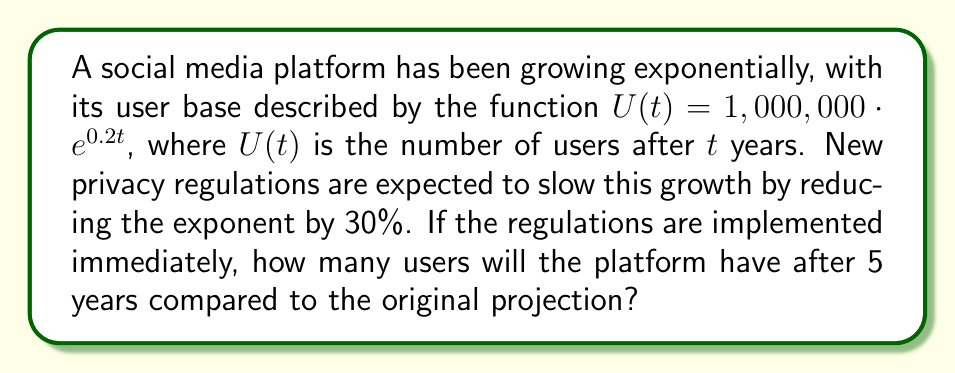Help me with this question. Let's approach this step-by-step:

1) The original growth function is:
   $U(t) = 1,000,000 \cdot e^{0.2t}$

2) After the 30% reduction in the exponent, the new growth function becomes:
   $U_{new}(t) = 1,000,000 \cdot e^{0.2 \cdot 0.7t} = 1,000,000 \cdot e^{0.14t}$

3) To find the number of users after 5 years with the original projection:
   $U(5) = 1,000,000 \cdot e^{0.2 \cdot 5} = 1,000,000 \cdot e^1 \approx 2,718,282$

4) To find the number of users after 5 years with the new regulations:
   $U_{new}(5) = 1,000,000 \cdot e^{0.14 \cdot 5} = 1,000,000 \cdot e^{0.7} \approx 2,013,753$

5) To compare, we calculate the difference:
   $2,718,282 - 2,013,753 = 704,529$

Therefore, after 5 years, the platform will have approximately 704,529 fewer users than originally projected due to the new privacy regulations.
Answer: The platform will have approximately 704,529 fewer users after 5 years compared to the original projection. 